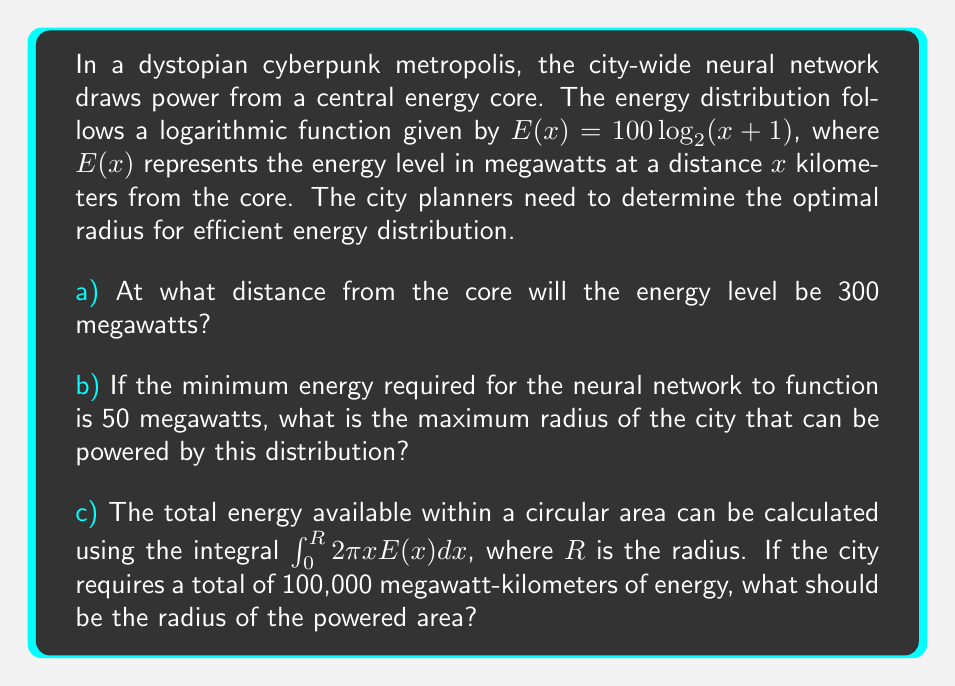Give your solution to this math problem. Let's approach this problem step by step, blending the cyberpunk aesthetic with mathematical rigor:

a) We need to solve the equation:
   $300 = 100 \log_2(x+1)$
   
   Dividing both sides by 100:
   $3 = \log_2(x+1)$
   
   Applying $2^x$ to both sides:
   $2^3 = x+1$
   $8 = x+1$
   $x = 7$

   Therefore, the energy level will be 300 megawatts at a distance of 7 kilometers from the core.

b) We need to solve:
   $50 = 100 \log_2(x+1)$
   $0.5 = \log_2(x+1)$
   $2^{0.5} = x+1$
   $\sqrt{2} = x+1$
   $x = \sqrt{2} - 1 \approx 0.414$

   The maximum radius is approximately 0.414 kilometers or 414 meters.

c) We need to solve the integral equation:
   $$100,000 = \int_0^R 2\pi x [100 \log_2(x+1)] dx$$

   This integral doesn't have a simple closed form. We can solve it numerically using computational methods. Using a numerical solver, we find that:

   $R \approx 5.103$ kilometers

   This result can be verified by plugging it back into the integral and evaluating numerically.
Answer: a) 7 kilometers
b) 0.414 kilometers (or 414 meters)
c) 5.103 kilometers 